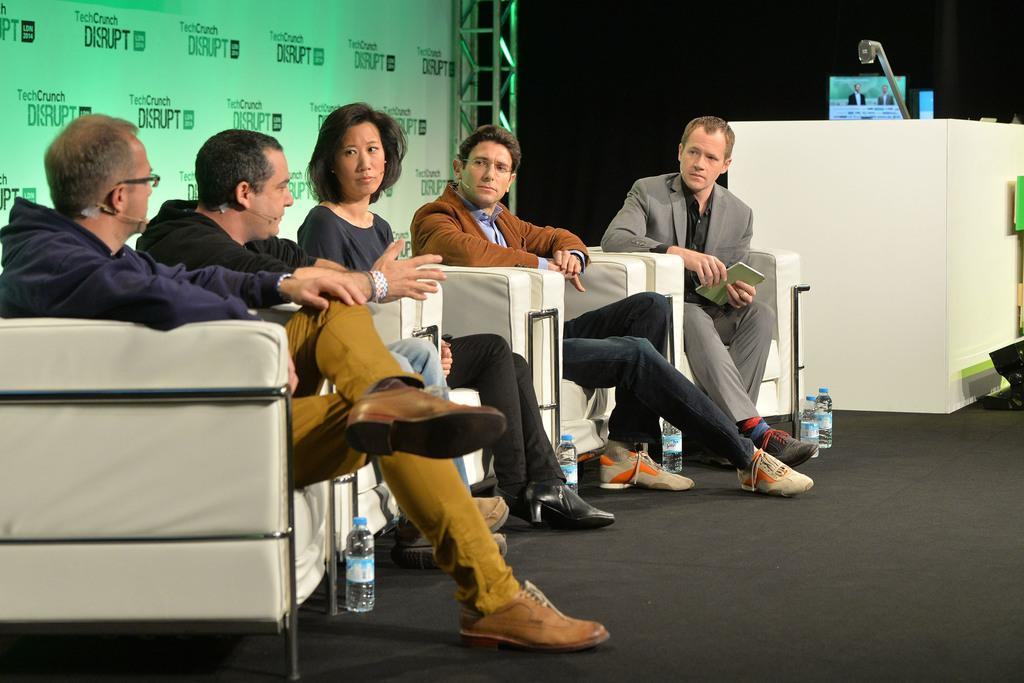Who is present in the image? There are men and a woman in the image. What are the people in the image doing? The people are sitting on chairs. What can be seen on the ground in the background? There are bottles on the ground in the background. What is located on the right side of the image? There is a board on the right side of the image. What other objects can be seen in the image? There is a podium and a screen in the image. What type of haircut is the woman getting in the image? There is no haircut being performed in the image; the people are sitting on chairs, but no haircut is visible. What is the temperature like in the image? The temperature cannot be determined from the image, as there is no information about the weather or environment provided. 